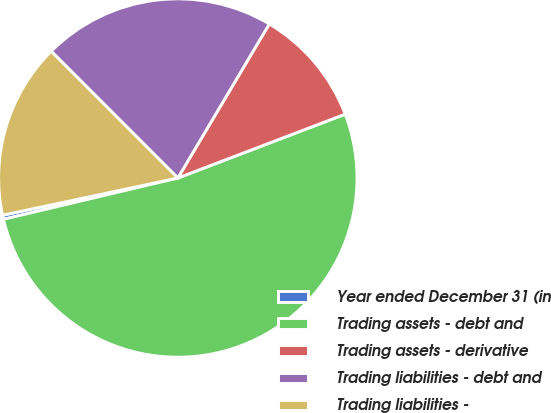<chart> <loc_0><loc_0><loc_500><loc_500><pie_chart><fcel>Year ended December 31 (in<fcel>Trading assets - debt and<fcel>Trading assets - derivative<fcel>Trading liabilities - debt and<fcel>Trading liabilities -<nl><fcel>0.37%<fcel>52.1%<fcel>10.67%<fcel>21.02%<fcel>15.84%<nl></chart> 